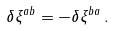Convert formula to latex. <formula><loc_0><loc_0><loc_500><loc_500>\delta \xi ^ { a b } = - \delta \xi ^ { b a } \, .</formula> 